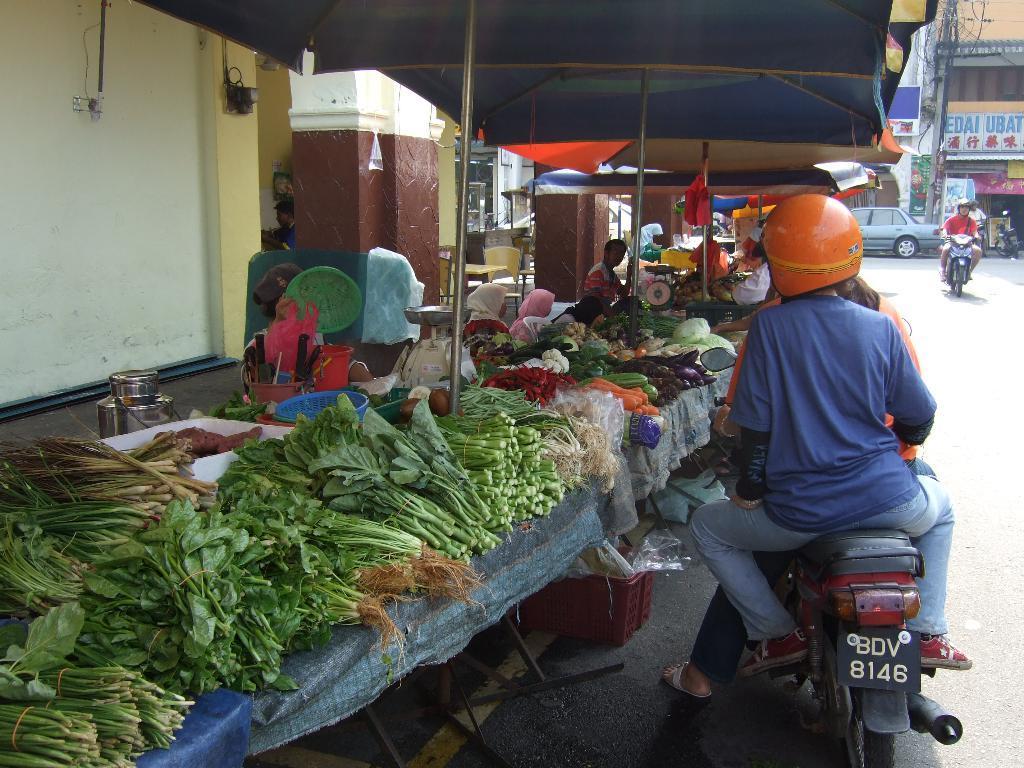Could you give a brief overview of what you see in this image? As we can see in the image there is a wall, few vegetables on tables and a car and motor cycle on road and there is a building. 